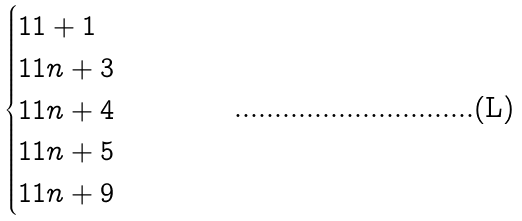Convert formula to latex. <formula><loc_0><loc_0><loc_500><loc_500>\begin{cases} 1 1 + 1 \\ 1 1 n + 3 \\ 1 1 n + 4 \\ 1 1 n + 5 \\ 1 1 n + 9 \end{cases}</formula> 